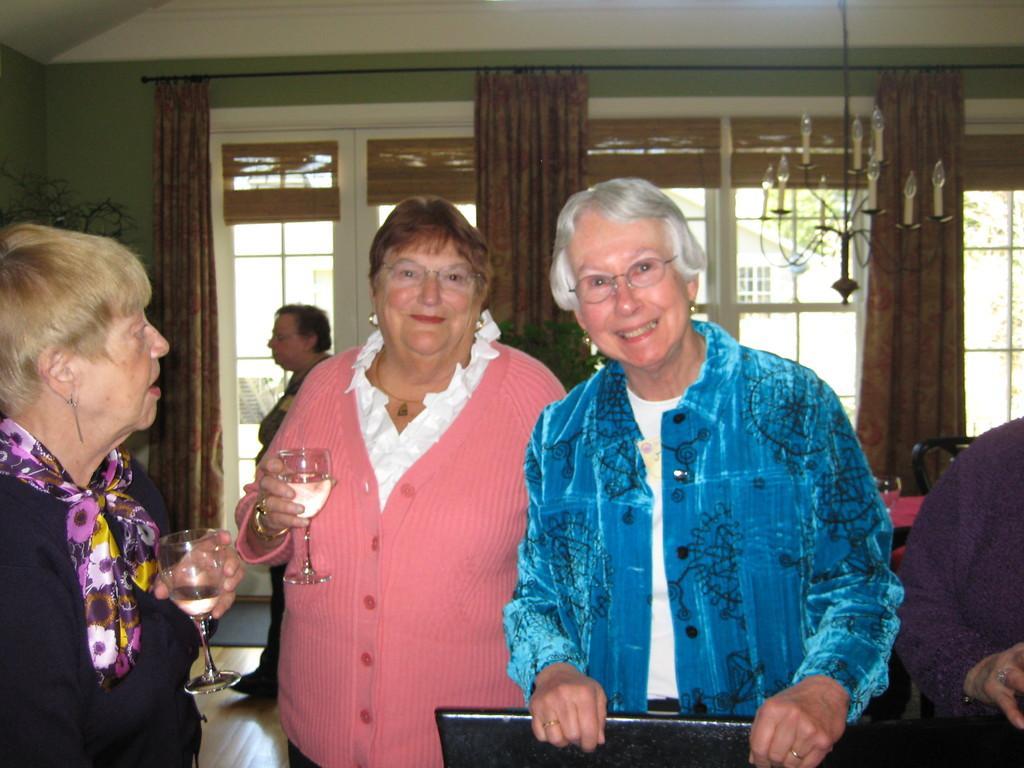Describe this image in one or two sentences. In this image I can see a person wearing blue and white colored dress, another person wearing pink and white colored dress and another woman wearing pink and black colored dress are standing and I can see two of them are holding glasses in their hands. In the background I can see another woman, the green colored wall, the brown colored curtain and the window through which I can see another building. 